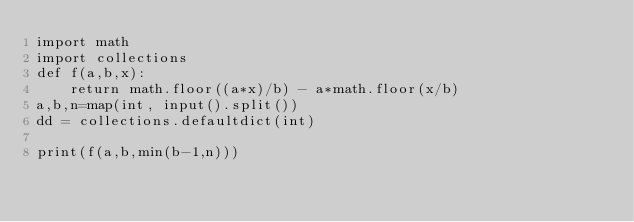Convert code to text. <code><loc_0><loc_0><loc_500><loc_500><_Python_>import math
import collections
def f(a,b,x):
    return math.floor((a*x)/b) - a*math.floor(x/b)
a,b,n=map(int, input().split())
dd = collections.defaultdict(int)

print(f(a,b,min(b-1,n)))
</code> 